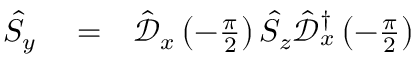<formula> <loc_0><loc_0><loc_500><loc_500>\begin{array} { r l r } { \hat { S } _ { y } } & = } & { \hat { \mathcal { D } } _ { x } \left ( - \frac { \pi } { 2 } \right ) \hat { S } _ { z } \hat { \mathcal { D } } _ { x } ^ { \dagger } \left ( - \frac { \pi } { 2 } \right ) } \end{array}</formula> 